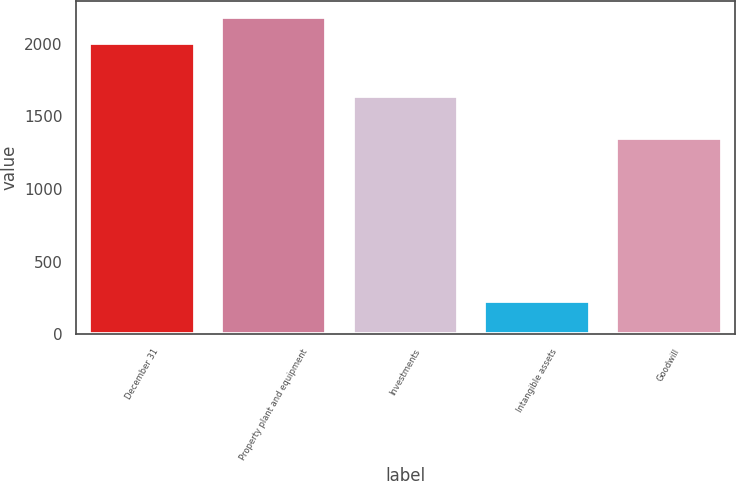Convert chart to OTSL. <chart><loc_0><loc_0><loc_500><loc_500><bar_chart><fcel>December 31<fcel>Property plant and equipment<fcel>Investments<fcel>Intangible assets<fcel>Goodwill<nl><fcel>2005<fcel>2183.9<fcel>1644<fcel>231<fcel>1349<nl></chart> 